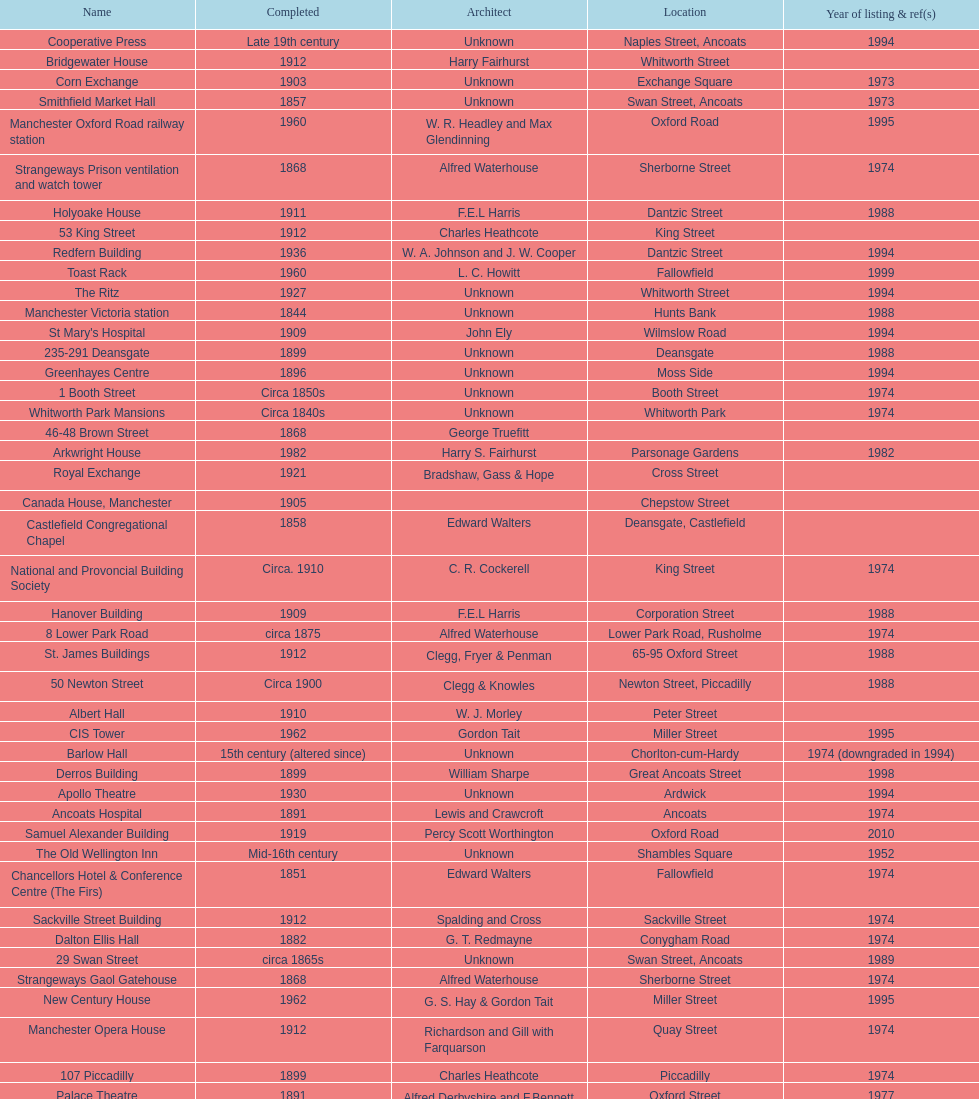Which year has the most buildings listed? 1974. 